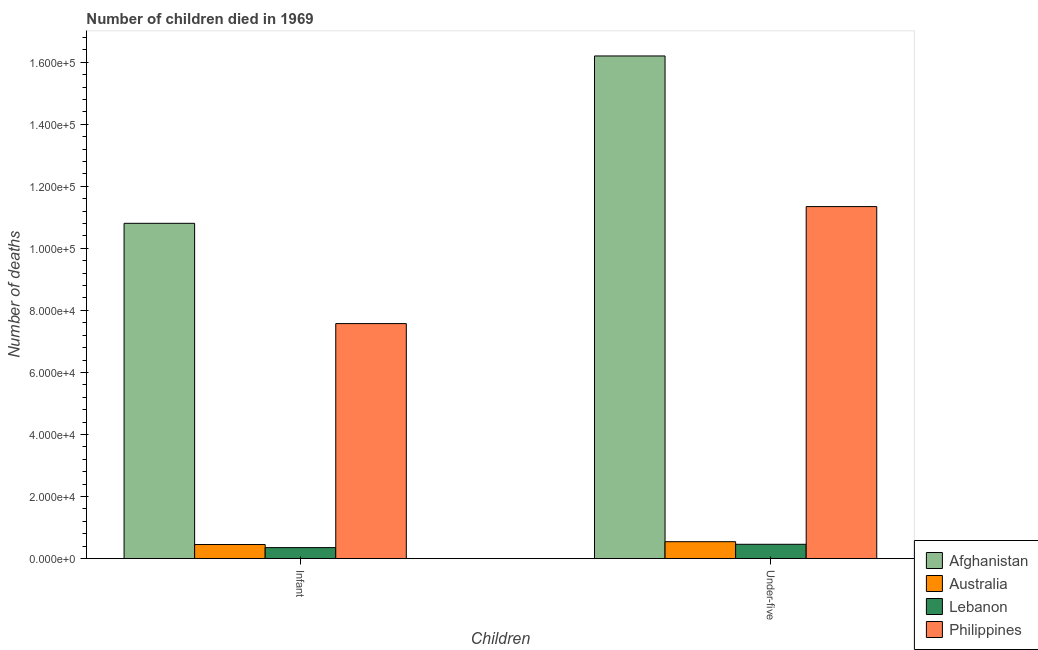How many groups of bars are there?
Your answer should be compact. 2. How many bars are there on the 2nd tick from the right?
Ensure brevity in your answer.  4. What is the label of the 2nd group of bars from the left?
Offer a terse response. Under-five. What is the number of under-five deaths in Australia?
Ensure brevity in your answer.  5438. Across all countries, what is the maximum number of infant deaths?
Offer a terse response. 1.08e+05. Across all countries, what is the minimum number of infant deaths?
Offer a very short reply. 3530. In which country was the number of under-five deaths maximum?
Make the answer very short. Afghanistan. In which country was the number of under-five deaths minimum?
Your response must be concise. Lebanon. What is the total number of infant deaths in the graph?
Your answer should be compact. 1.92e+05. What is the difference between the number of under-five deaths in Lebanon and that in Australia?
Your answer should be compact. -836. What is the difference between the number of under-five deaths in Afghanistan and the number of infant deaths in Australia?
Provide a short and direct response. 1.57e+05. What is the average number of infant deaths per country?
Keep it short and to the point. 4.80e+04. What is the difference between the number of under-five deaths and number of infant deaths in Australia?
Provide a short and direct response. 908. What is the ratio of the number of under-five deaths in Philippines to that in Afghanistan?
Provide a succinct answer. 0.7. What does the 3rd bar from the left in Infant represents?
Your answer should be compact. Lebanon. What is the difference between two consecutive major ticks on the Y-axis?
Your answer should be compact. 2.00e+04. Are the values on the major ticks of Y-axis written in scientific E-notation?
Offer a very short reply. Yes. Does the graph contain any zero values?
Make the answer very short. No. Does the graph contain grids?
Your response must be concise. No. How many legend labels are there?
Your response must be concise. 4. What is the title of the graph?
Ensure brevity in your answer.  Number of children died in 1969. Does "Niger" appear as one of the legend labels in the graph?
Ensure brevity in your answer.  No. What is the label or title of the X-axis?
Ensure brevity in your answer.  Children. What is the label or title of the Y-axis?
Your answer should be very brief. Number of deaths. What is the Number of deaths in Afghanistan in Infant?
Your answer should be very brief. 1.08e+05. What is the Number of deaths of Australia in Infant?
Provide a succinct answer. 4530. What is the Number of deaths in Lebanon in Infant?
Keep it short and to the point. 3530. What is the Number of deaths of Philippines in Infant?
Your response must be concise. 7.58e+04. What is the Number of deaths in Afghanistan in Under-five?
Your answer should be very brief. 1.62e+05. What is the Number of deaths of Australia in Under-five?
Give a very brief answer. 5438. What is the Number of deaths in Lebanon in Under-five?
Your answer should be compact. 4602. What is the Number of deaths in Philippines in Under-five?
Offer a very short reply. 1.13e+05. Across all Children, what is the maximum Number of deaths of Afghanistan?
Provide a short and direct response. 1.62e+05. Across all Children, what is the maximum Number of deaths of Australia?
Make the answer very short. 5438. Across all Children, what is the maximum Number of deaths in Lebanon?
Your answer should be very brief. 4602. Across all Children, what is the maximum Number of deaths in Philippines?
Your response must be concise. 1.13e+05. Across all Children, what is the minimum Number of deaths in Afghanistan?
Provide a succinct answer. 1.08e+05. Across all Children, what is the minimum Number of deaths in Australia?
Ensure brevity in your answer.  4530. Across all Children, what is the minimum Number of deaths of Lebanon?
Provide a short and direct response. 3530. Across all Children, what is the minimum Number of deaths in Philippines?
Your response must be concise. 7.58e+04. What is the total Number of deaths in Afghanistan in the graph?
Offer a terse response. 2.70e+05. What is the total Number of deaths of Australia in the graph?
Provide a succinct answer. 9968. What is the total Number of deaths of Lebanon in the graph?
Keep it short and to the point. 8132. What is the total Number of deaths in Philippines in the graph?
Make the answer very short. 1.89e+05. What is the difference between the Number of deaths of Afghanistan in Infant and that in Under-five?
Your response must be concise. -5.40e+04. What is the difference between the Number of deaths in Australia in Infant and that in Under-five?
Give a very brief answer. -908. What is the difference between the Number of deaths of Lebanon in Infant and that in Under-five?
Your answer should be compact. -1072. What is the difference between the Number of deaths in Philippines in Infant and that in Under-five?
Your answer should be very brief. -3.77e+04. What is the difference between the Number of deaths in Afghanistan in Infant and the Number of deaths in Australia in Under-five?
Ensure brevity in your answer.  1.03e+05. What is the difference between the Number of deaths of Afghanistan in Infant and the Number of deaths of Lebanon in Under-five?
Ensure brevity in your answer.  1.03e+05. What is the difference between the Number of deaths of Afghanistan in Infant and the Number of deaths of Philippines in Under-five?
Your response must be concise. -5395. What is the difference between the Number of deaths of Australia in Infant and the Number of deaths of Lebanon in Under-five?
Give a very brief answer. -72. What is the difference between the Number of deaths in Australia in Infant and the Number of deaths in Philippines in Under-five?
Give a very brief answer. -1.09e+05. What is the difference between the Number of deaths of Lebanon in Infant and the Number of deaths of Philippines in Under-five?
Your answer should be compact. -1.10e+05. What is the average Number of deaths of Afghanistan per Children?
Make the answer very short. 1.35e+05. What is the average Number of deaths in Australia per Children?
Make the answer very short. 4984. What is the average Number of deaths in Lebanon per Children?
Keep it short and to the point. 4066. What is the average Number of deaths of Philippines per Children?
Provide a succinct answer. 9.46e+04. What is the difference between the Number of deaths of Afghanistan and Number of deaths of Australia in Infant?
Offer a terse response. 1.04e+05. What is the difference between the Number of deaths of Afghanistan and Number of deaths of Lebanon in Infant?
Ensure brevity in your answer.  1.05e+05. What is the difference between the Number of deaths in Afghanistan and Number of deaths in Philippines in Infant?
Your answer should be compact. 3.23e+04. What is the difference between the Number of deaths of Australia and Number of deaths of Lebanon in Infant?
Your answer should be compact. 1000. What is the difference between the Number of deaths in Australia and Number of deaths in Philippines in Infant?
Your answer should be very brief. -7.12e+04. What is the difference between the Number of deaths of Lebanon and Number of deaths of Philippines in Infant?
Offer a terse response. -7.22e+04. What is the difference between the Number of deaths in Afghanistan and Number of deaths in Australia in Under-five?
Offer a very short reply. 1.57e+05. What is the difference between the Number of deaths in Afghanistan and Number of deaths in Lebanon in Under-five?
Ensure brevity in your answer.  1.57e+05. What is the difference between the Number of deaths in Afghanistan and Number of deaths in Philippines in Under-five?
Offer a very short reply. 4.86e+04. What is the difference between the Number of deaths of Australia and Number of deaths of Lebanon in Under-five?
Your answer should be compact. 836. What is the difference between the Number of deaths in Australia and Number of deaths in Philippines in Under-five?
Your response must be concise. -1.08e+05. What is the difference between the Number of deaths of Lebanon and Number of deaths of Philippines in Under-five?
Offer a terse response. -1.09e+05. What is the ratio of the Number of deaths in Afghanistan in Infant to that in Under-five?
Your response must be concise. 0.67. What is the ratio of the Number of deaths of Australia in Infant to that in Under-five?
Provide a short and direct response. 0.83. What is the ratio of the Number of deaths of Lebanon in Infant to that in Under-five?
Provide a succinct answer. 0.77. What is the ratio of the Number of deaths in Philippines in Infant to that in Under-five?
Provide a succinct answer. 0.67. What is the difference between the highest and the second highest Number of deaths in Afghanistan?
Offer a very short reply. 5.40e+04. What is the difference between the highest and the second highest Number of deaths in Australia?
Your answer should be compact. 908. What is the difference between the highest and the second highest Number of deaths of Lebanon?
Provide a succinct answer. 1072. What is the difference between the highest and the second highest Number of deaths in Philippines?
Offer a very short reply. 3.77e+04. What is the difference between the highest and the lowest Number of deaths in Afghanistan?
Make the answer very short. 5.40e+04. What is the difference between the highest and the lowest Number of deaths in Australia?
Offer a very short reply. 908. What is the difference between the highest and the lowest Number of deaths of Lebanon?
Offer a terse response. 1072. What is the difference between the highest and the lowest Number of deaths in Philippines?
Your answer should be very brief. 3.77e+04. 